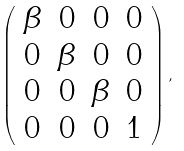<formula> <loc_0><loc_0><loc_500><loc_500>\left ( \begin{array} { c c c c } \beta & 0 & 0 & 0 \\ 0 & \beta & 0 & 0 \\ 0 & 0 & \beta & 0 \\ 0 & 0 & 0 & 1 \end{array} \right ) ,</formula> 